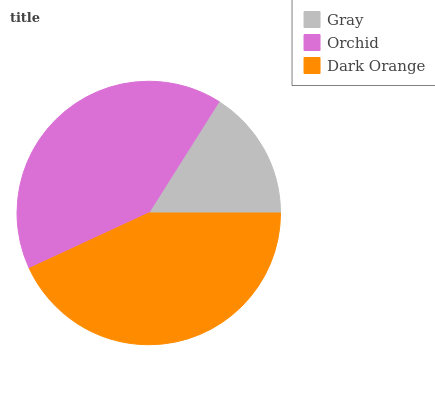Is Gray the minimum?
Answer yes or no. Yes. Is Dark Orange the maximum?
Answer yes or no. Yes. Is Orchid the minimum?
Answer yes or no. No. Is Orchid the maximum?
Answer yes or no. No. Is Orchid greater than Gray?
Answer yes or no. Yes. Is Gray less than Orchid?
Answer yes or no. Yes. Is Gray greater than Orchid?
Answer yes or no. No. Is Orchid less than Gray?
Answer yes or no. No. Is Orchid the high median?
Answer yes or no. Yes. Is Orchid the low median?
Answer yes or no. Yes. Is Dark Orange the high median?
Answer yes or no. No. Is Dark Orange the low median?
Answer yes or no. No. 